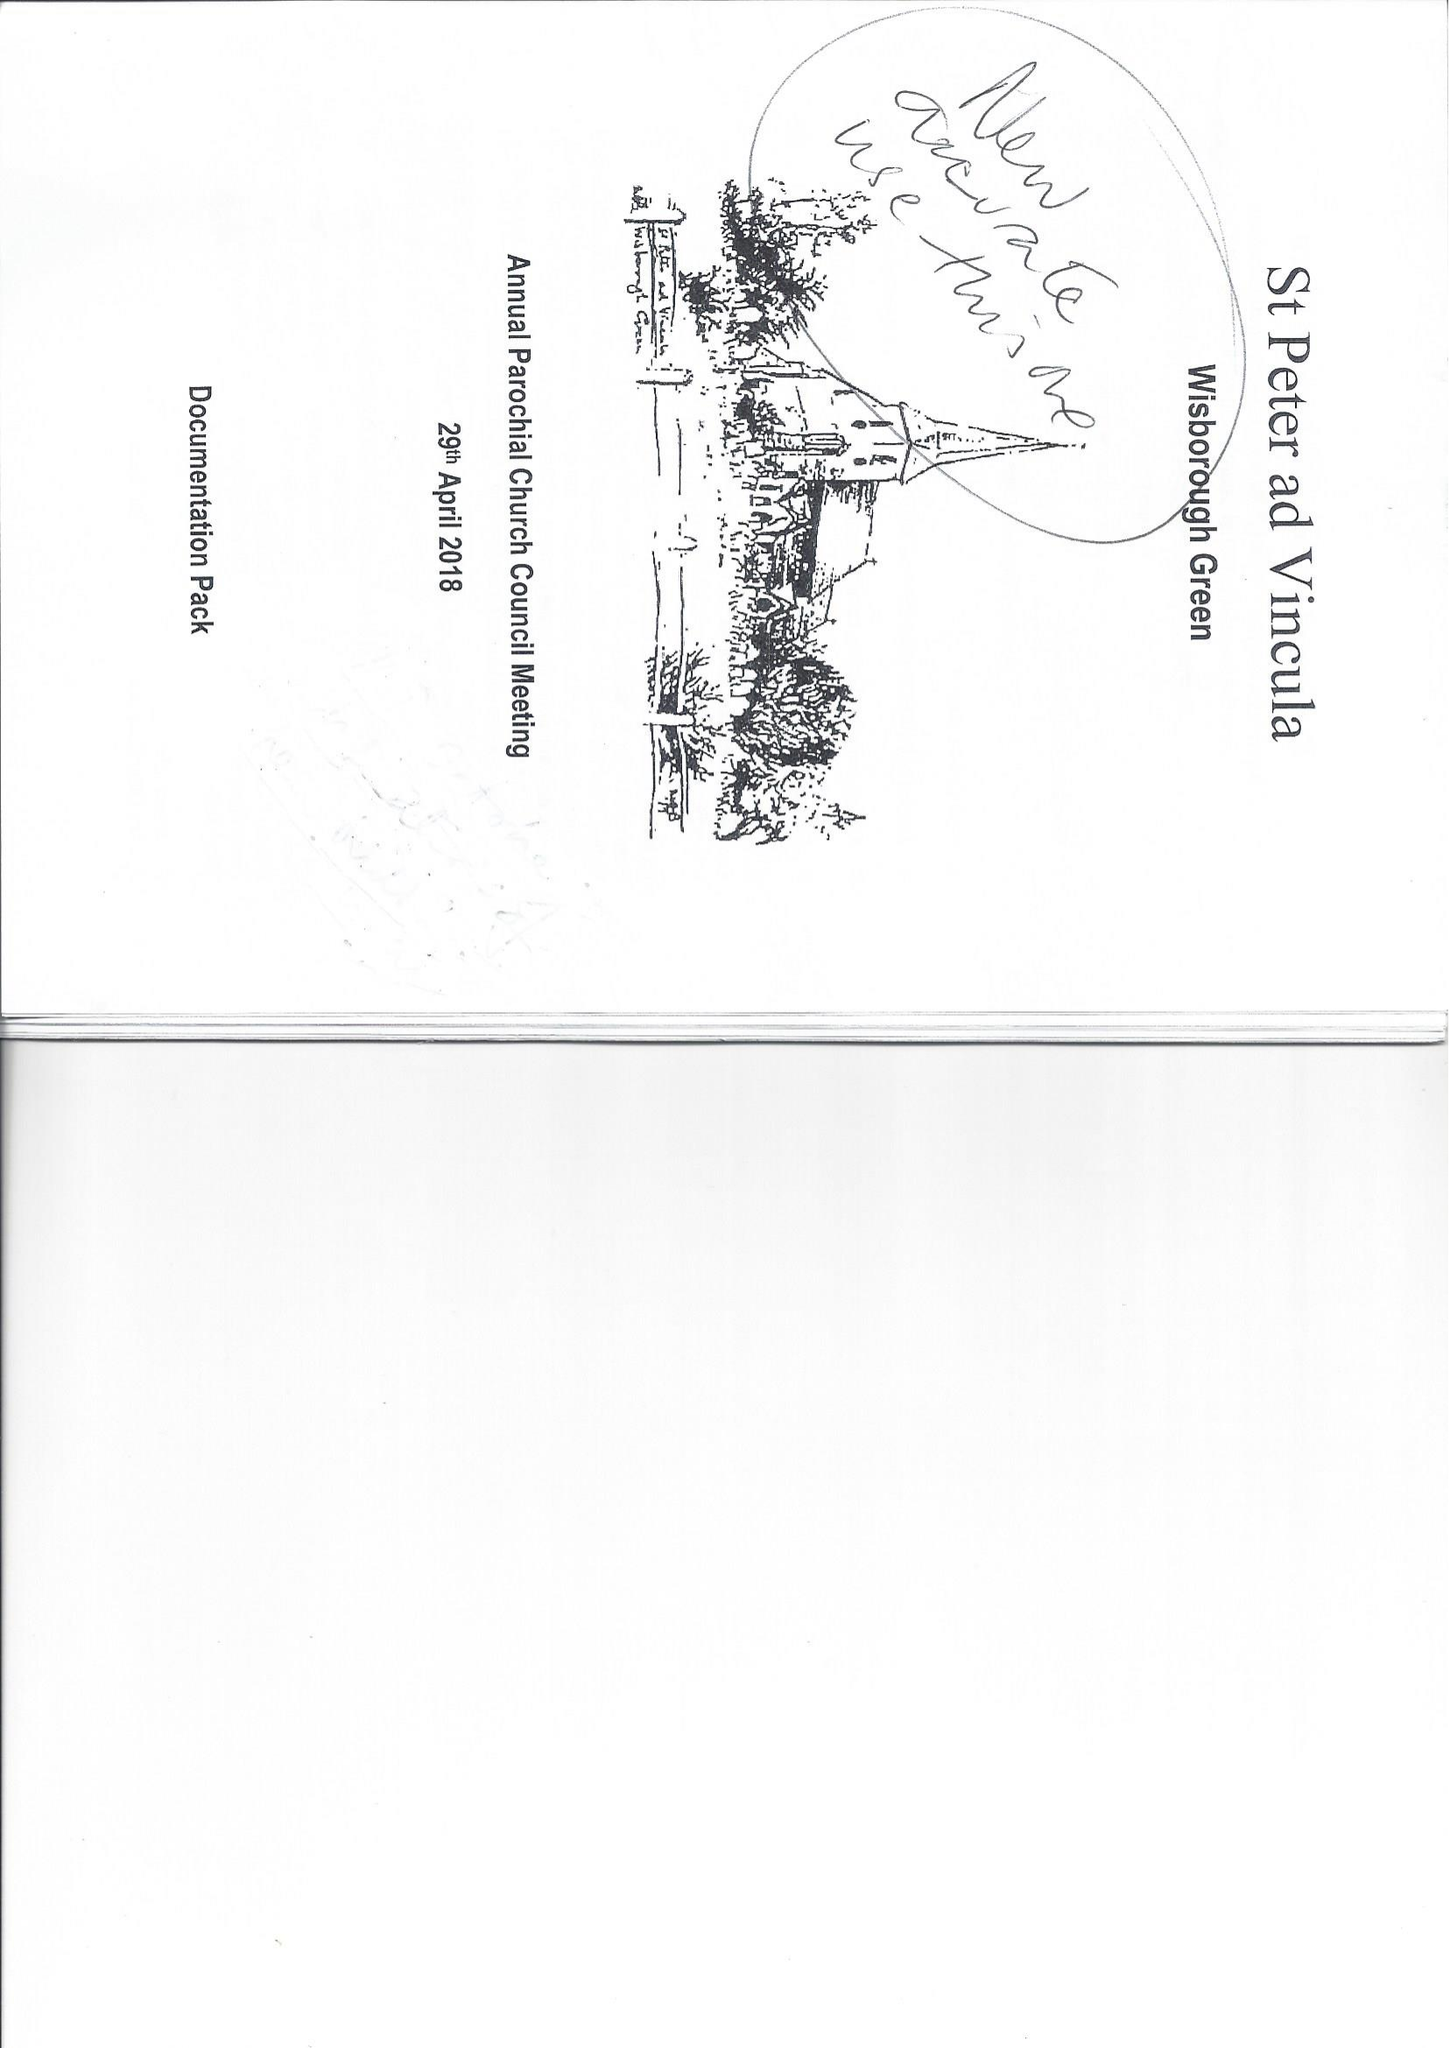What is the value for the charity_number?
Answer the question using a single word or phrase. 1133950 